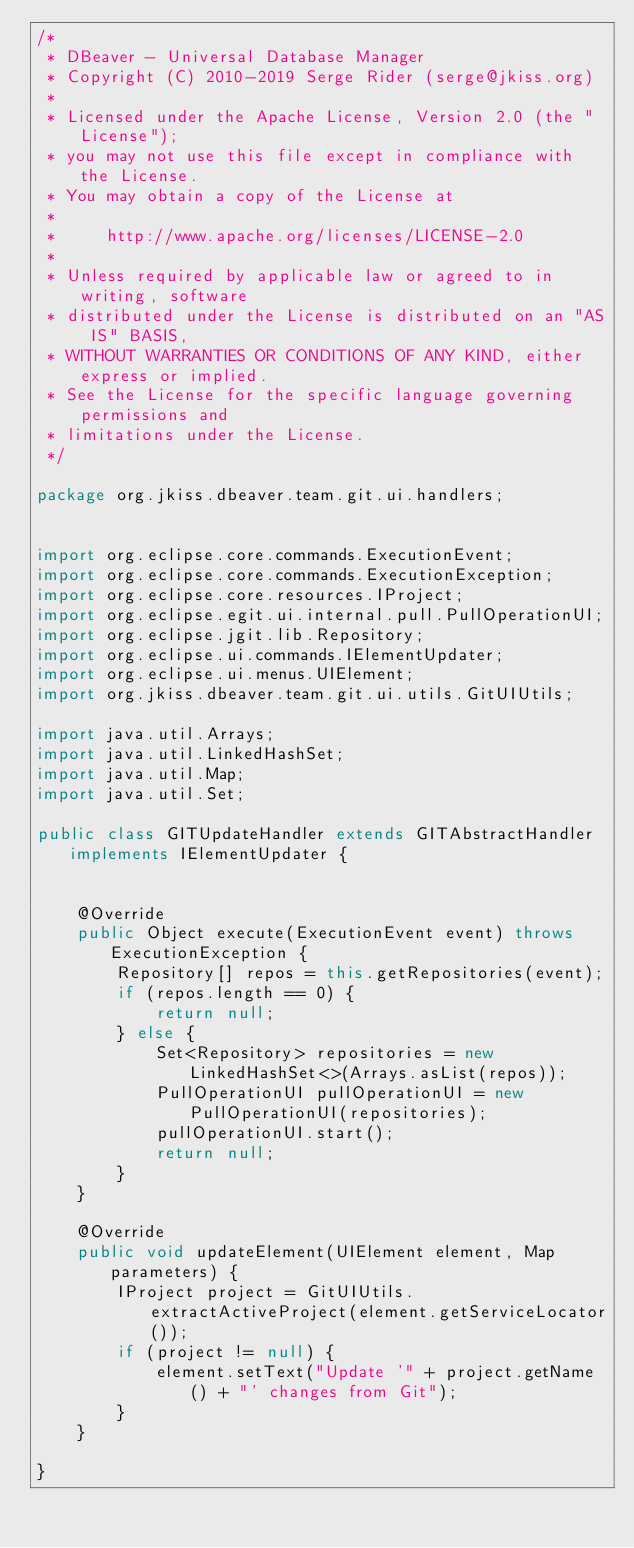Convert code to text. <code><loc_0><loc_0><loc_500><loc_500><_Java_>/*
 * DBeaver - Universal Database Manager
 * Copyright (C) 2010-2019 Serge Rider (serge@jkiss.org)
 *
 * Licensed under the Apache License, Version 2.0 (the "License");
 * you may not use this file except in compliance with the License.
 * You may obtain a copy of the License at
 *
 *     http://www.apache.org/licenses/LICENSE-2.0
 *
 * Unless required by applicable law or agreed to in writing, software
 * distributed under the License is distributed on an "AS IS" BASIS,
 * WITHOUT WARRANTIES OR CONDITIONS OF ANY KIND, either express or implied.
 * See the License for the specific language governing permissions and
 * limitations under the License.
 */

package org.jkiss.dbeaver.team.git.ui.handlers;


import org.eclipse.core.commands.ExecutionEvent;
import org.eclipse.core.commands.ExecutionException;
import org.eclipse.core.resources.IProject;
import org.eclipse.egit.ui.internal.pull.PullOperationUI;
import org.eclipse.jgit.lib.Repository;
import org.eclipse.ui.commands.IElementUpdater;
import org.eclipse.ui.menus.UIElement;
import org.jkiss.dbeaver.team.git.ui.utils.GitUIUtils;

import java.util.Arrays;
import java.util.LinkedHashSet;
import java.util.Map;
import java.util.Set;

public class GITUpdateHandler extends GITAbstractHandler implements IElementUpdater {


    @Override
    public Object execute(ExecutionEvent event) throws ExecutionException {
        Repository[] repos = this.getRepositories(event);
        if (repos.length == 0) {
            return null;
        } else {
            Set<Repository> repositories = new LinkedHashSet<>(Arrays.asList(repos));
            PullOperationUI pullOperationUI = new PullOperationUI(repositories);
            pullOperationUI.start();
            return null;
        }
    }

    @Override
    public void updateElement(UIElement element, Map parameters) {
        IProject project = GitUIUtils.extractActiveProject(element.getServiceLocator());
        if (project != null) {
            element.setText("Update '" + project.getName() + "' changes from Git");
        }
    }

}
</code> 